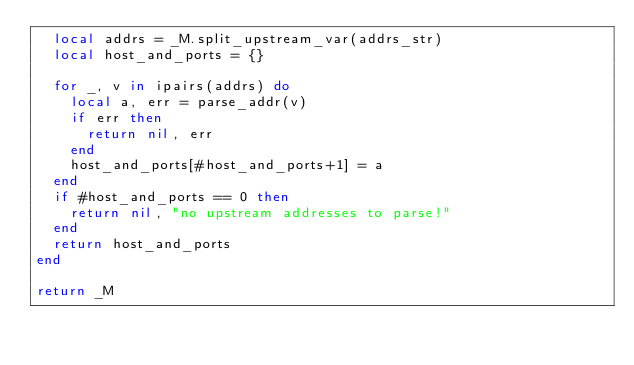Convert code to text. <code><loc_0><loc_0><loc_500><loc_500><_Lua_>  local addrs = _M.split_upstream_var(addrs_str)
  local host_and_ports = {}

  for _, v in ipairs(addrs) do
    local a, err = parse_addr(v)
    if err then
      return nil, err
    end
    host_and_ports[#host_and_ports+1] = a
  end
  if #host_and_ports == 0 then
    return nil, "no upstream addresses to parse!"
  end
  return host_and_ports
end

return _M
</code> 